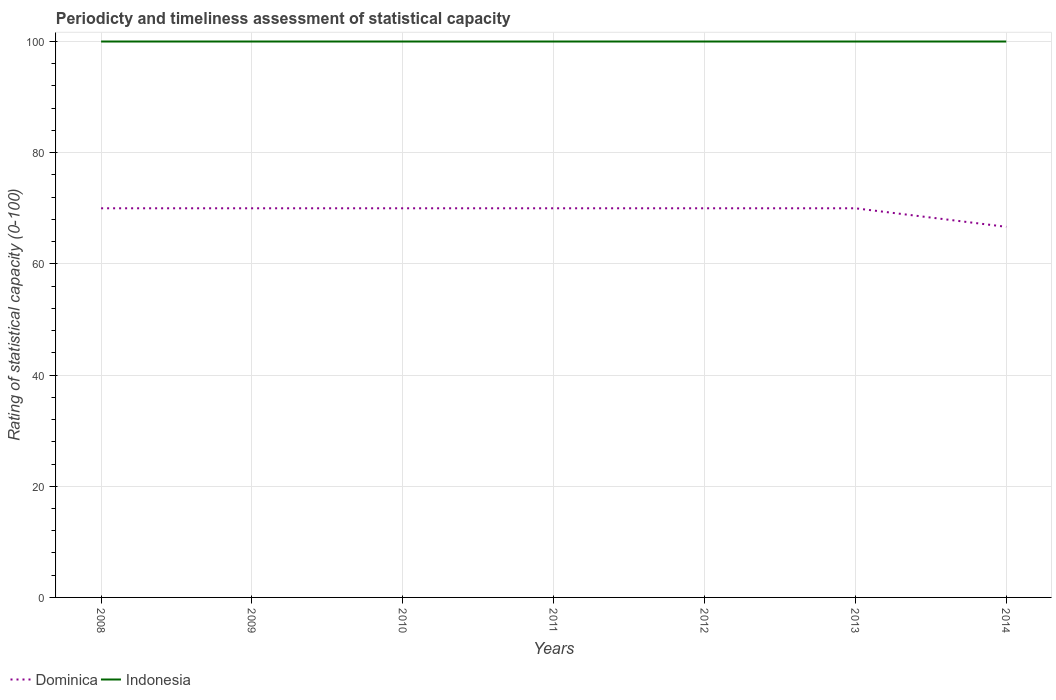Does the line corresponding to Dominica intersect with the line corresponding to Indonesia?
Ensure brevity in your answer.  No. What is the difference between the highest and the second highest rating of statistical capacity in Dominica?
Provide a succinct answer. 3.33. Is the rating of statistical capacity in Dominica strictly greater than the rating of statistical capacity in Indonesia over the years?
Your response must be concise. Yes. Are the values on the major ticks of Y-axis written in scientific E-notation?
Keep it short and to the point. No. Does the graph contain grids?
Keep it short and to the point. Yes. How many legend labels are there?
Your answer should be compact. 2. How are the legend labels stacked?
Give a very brief answer. Horizontal. What is the title of the graph?
Offer a terse response. Periodicty and timeliness assessment of statistical capacity. What is the label or title of the Y-axis?
Offer a terse response. Rating of statistical capacity (0-100). What is the Rating of statistical capacity (0-100) in Dominica in 2008?
Your answer should be very brief. 70. What is the Rating of statistical capacity (0-100) of Dominica in 2009?
Make the answer very short. 70. What is the Rating of statistical capacity (0-100) in Dominica in 2012?
Ensure brevity in your answer.  70. What is the Rating of statistical capacity (0-100) of Dominica in 2013?
Provide a short and direct response. 70. What is the Rating of statistical capacity (0-100) in Indonesia in 2013?
Provide a succinct answer. 100. What is the Rating of statistical capacity (0-100) of Dominica in 2014?
Give a very brief answer. 66.67. What is the Rating of statistical capacity (0-100) of Indonesia in 2014?
Your response must be concise. 100. Across all years, what is the minimum Rating of statistical capacity (0-100) of Dominica?
Keep it short and to the point. 66.67. Across all years, what is the minimum Rating of statistical capacity (0-100) in Indonesia?
Ensure brevity in your answer.  100. What is the total Rating of statistical capacity (0-100) in Dominica in the graph?
Make the answer very short. 486.67. What is the total Rating of statistical capacity (0-100) of Indonesia in the graph?
Your answer should be compact. 700. What is the difference between the Rating of statistical capacity (0-100) in Dominica in 2008 and that in 2009?
Offer a terse response. 0. What is the difference between the Rating of statistical capacity (0-100) in Indonesia in 2008 and that in 2009?
Your answer should be compact. 0. What is the difference between the Rating of statistical capacity (0-100) of Dominica in 2008 and that in 2010?
Make the answer very short. 0. What is the difference between the Rating of statistical capacity (0-100) in Dominica in 2008 and that in 2012?
Your answer should be compact. 0. What is the difference between the Rating of statistical capacity (0-100) in Dominica in 2008 and that in 2013?
Give a very brief answer. 0. What is the difference between the Rating of statistical capacity (0-100) of Indonesia in 2008 and that in 2013?
Ensure brevity in your answer.  0. What is the difference between the Rating of statistical capacity (0-100) in Indonesia in 2008 and that in 2014?
Offer a very short reply. 0. What is the difference between the Rating of statistical capacity (0-100) of Dominica in 2009 and that in 2010?
Make the answer very short. 0. What is the difference between the Rating of statistical capacity (0-100) of Indonesia in 2009 and that in 2010?
Offer a very short reply. 0. What is the difference between the Rating of statistical capacity (0-100) of Dominica in 2009 and that in 2011?
Your response must be concise. 0. What is the difference between the Rating of statistical capacity (0-100) of Indonesia in 2009 and that in 2012?
Provide a succinct answer. 0. What is the difference between the Rating of statistical capacity (0-100) in Dominica in 2009 and that in 2013?
Provide a short and direct response. 0. What is the difference between the Rating of statistical capacity (0-100) in Indonesia in 2009 and that in 2013?
Ensure brevity in your answer.  0. What is the difference between the Rating of statistical capacity (0-100) of Indonesia in 2009 and that in 2014?
Provide a short and direct response. 0. What is the difference between the Rating of statistical capacity (0-100) of Dominica in 2010 and that in 2012?
Offer a terse response. 0. What is the difference between the Rating of statistical capacity (0-100) of Dominica in 2010 and that in 2013?
Ensure brevity in your answer.  0. What is the difference between the Rating of statistical capacity (0-100) in Dominica in 2010 and that in 2014?
Provide a succinct answer. 3.33. What is the difference between the Rating of statistical capacity (0-100) in Dominica in 2011 and that in 2012?
Provide a short and direct response. 0. What is the difference between the Rating of statistical capacity (0-100) in Dominica in 2011 and that in 2013?
Your answer should be very brief. 0. What is the difference between the Rating of statistical capacity (0-100) in Indonesia in 2011 and that in 2013?
Offer a terse response. 0. What is the difference between the Rating of statistical capacity (0-100) of Dominica in 2008 and the Rating of statistical capacity (0-100) of Indonesia in 2010?
Offer a very short reply. -30. What is the difference between the Rating of statistical capacity (0-100) in Dominica in 2008 and the Rating of statistical capacity (0-100) in Indonesia in 2011?
Your answer should be compact. -30. What is the difference between the Rating of statistical capacity (0-100) in Dominica in 2008 and the Rating of statistical capacity (0-100) in Indonesia in 2012?
Give a very brief answer. -30. What is the difference between the Rating of statistical capacity (0-100) of Dominica in 2008 and the Rating of statistical capacity (0-100) of Indonesia in 2013?
Make the answer very short. -30. What is the difference between the Rating of statistical capacity (0-100) in Dominica in 2009 and the Rating of statistical capacity (0-100) in Indonesia in 2010?
Offer a terse response. -30. What is the difference between the Rating of statistical capacity (0-100) in Dominica in 2009 and the Rating of statistical capacity (0-100) in Indonesia in 2012?
Provide a short and direct response. -30. What is the difference between the Rating of statistical capacity (0-100) of Dominica in 2010 and the Rating of statistical capacity (0-100) of Indonesia in 2012?
Provide a short and direct response. -30. What is the difference between the Rating of statistical capacity (0-100) of Dominica in 2012 and the Rating of statistical capacity (0-100) of Indonesia in 2013?
Ensure brevity in your answer.  -30. What is the average Rating of statistical capacity (0-100) of Dominica per year?
Offer a terse response. 69.52. What is the average Rating of statistical capacity (0-100) of Indonesia per year?
Your response must be concise. 100. In the year 2011, what is the difference between the Rating of statistical capacity (0-100) of Dominica and Rating of statistical capacity (0-100) of Indonesia?
Make the answer very short. -30. In the year 2012, what is the difference between the Rating of statistical capacity (0-100) in Dominica and Rating of statistical capacity (0-100) in Indonesia?
Keep it short and to the point. -30. In the year 2013, what is the difference between the Rating of statistical capacity (0-100) of Dominica and Rating of statistical capacity (0-100) of Indonesia?
Ensure brevity in your answer.  -30. In the year 2014, what is the difference between the Rating of statistical capacity (0-100) in Dominica and Rating of statistical capacity (0-100) in Indonesia?
Provide a succinct answer. -33.33. What is the ratio of the Rating of statistical capacity (0-100) of Indonesia in 2008 to that in 2009?
Your answer should be compact. 1. What is the ratio of the Rating of statistical capacity (0-100) in Dominica in 2008 to that in 2010?
Your response must be concise. 1. What is the ratio of the Rating of statistical capacity (0-100) of Indonesia in 2008 to that in 2010?
Your answer should be compact. 1. What is the ratio of the Rating of statistical capacity (0-100) in Dominica in 2008 to that in 2012?
Your answer should be very brief. 1. What is the ratio of the Rating of statistical capacity (0-100) in Dominica in 2008 to that in 2013?
Your response must be concise. 1. What is the ratio of the Rating of statistical capacity (0-100) of Dominica in 2008 to that in 2014?
Provide a short and direct response. 1.05. What is the ratio of the Rating of statistical capacity (0-100) in Dominica in 2009 to that in 2010?
Keep it short and to the point. 1. What is the ratio of the Rating of statistical capacity (0-100) of Dominica in 2009 to that in 2011?
Your answer should be very brief. 1. What is the ratio of the Rating of statistical capacity (0-100) in Dominica in 2009 to that in 2013?
Your answer should be compact. 1. What is the ratio of the Rating of statistical capacity (0-100) of Indonesia in 2009 to that in 2013?
Ensure brevity in your answer.  1. What is the ratio of the Rating of statistical capacity (0-100) of Dominica in 2009 to that in 2014?
Your answer should be compact. 1.05. What is the ratio of the Rating of statistical capacity (0-100) in Dominica in 2010 to that in 2011?
Keep it short and to the point. 1. What is the ratio of the Rating of statistical capacity (0-100) in Indonesia in 2010 to that in 2011?
Provide a succinct answer. 1. What is the ratio of the Rating of statistical capacity (0-100) in Dominica in 2010 to that in 2012?
Ensure brevity in your answer.  1. What is the ratio of the Rating of statistical capacity (0-100) of Dominica in 2010 to that in 2013?
Your answer should be compact. 1. What is the ratio of the Rating of statistical capacity (0-100) in Dominica in 2010 to that in 2014?
Your answer should be very brief. 1.05. What is the ratio of the Rating of statistical capacity (0-100) in Indonesia in 2010 to that in 2014?
Keep it short and to the point. 1. What is the ratio of the Rating of statistical capacity (0-100) in Dominica in 2011 to that in 2012?
Give a very brief answer. 1. What is the ratio of the Rating of statistical capacity (0-100) of Indonesia in 2011 to that in 2012?
Offer a very short reply. 1. What is the ratio of the Rating of statistical capacity (0-100) of Dominica in 2012 to that in 2014?
Provide a succinct answer. 1.05. What is the ratio of the Rating of statistical capacity (0-100) of Indonesia in 2013 to that in 2014?
Ensure brevity in your answer.  1. What is the difference between the highest and the lowest Rating of statistical capacity (0-100) in Indonesia?
Provide a succinct answer. 0. 